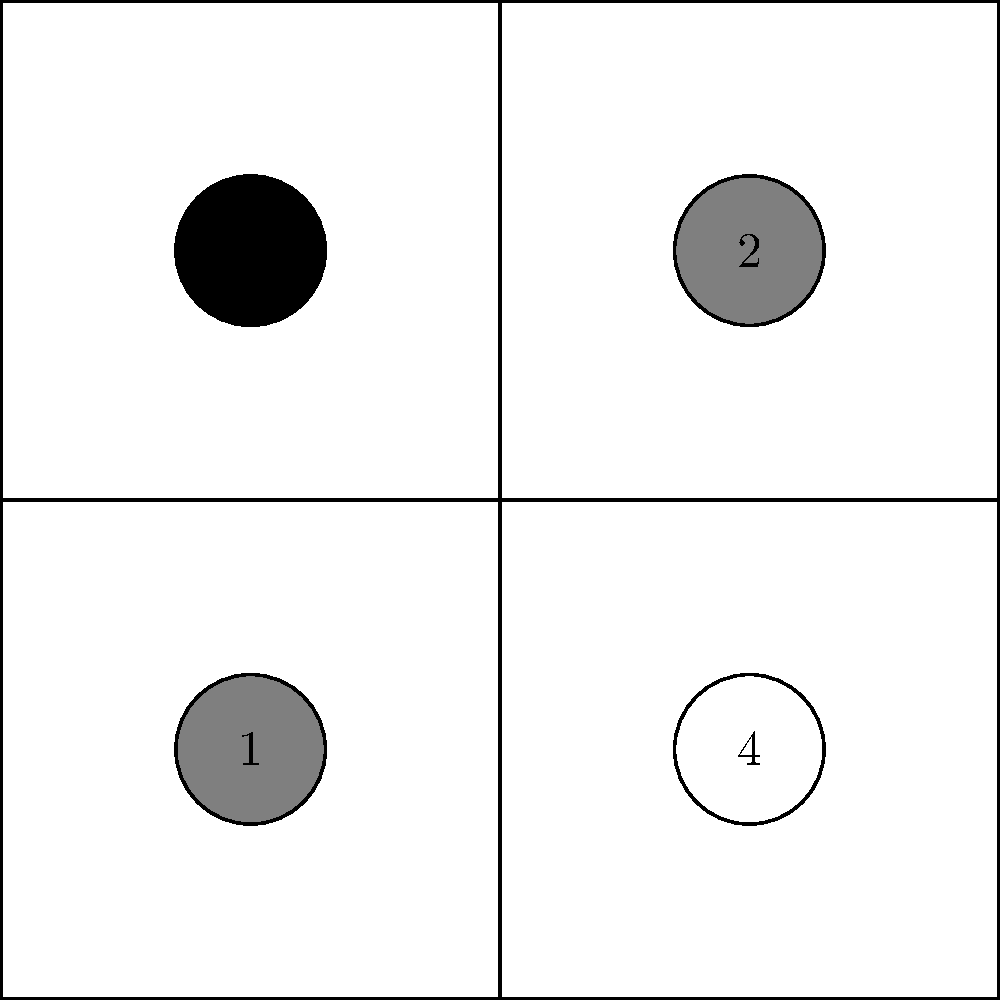As a humanitarian organization, you're selecting a photo composition for a campaign. The grid represents possible photo layouts, with circles indicating subject placement. Which composition (1, 2, 3, or 4) would likely create the most visually impactful and emotionally engaging image for your campaign? To determine the most visually impactful composition for a humanitarian aid photo, we need to consider several factors:

1. Rule of Thirds: In photography, the rule of thirds suggests that placing subjects along the lines or at the intersections of a 3x3 grid creates more engaging images.

2. Visual Weight: Objects placed in certain areas of the frame carry more visual weight and draw more attention.

3. Emotional Impact: For humanitarian campaigns, images that evoke emotion are crucial.

4. Balanced vs. Unbalanced Composition: Balanced compositions feel stable, while unbalanced ones create tension and interest.

Analyzing each option:

1. Bottom-left: Centered and low, lacks visual interest.
2. Top-right: Centered and high, also lacks visual interest.
3. Top-left: Follows the rule of thirds, creates visual tension.
4. Bottom-right: Follows the rule of thirds, but less impactful than top-left.

Option 3 (top-left) is the most impactful because:
- It follows the rule of thirds, placing the subject at a power point.
- The top-left position creates visual tension, drawing the viewer's eye.
- It leaves space for the subject to "look" into the frame, creating a sense of story or context.
- This composition often evokes empathy and curiosity, ideal for humanitarian campaigns.
Answer: 3 